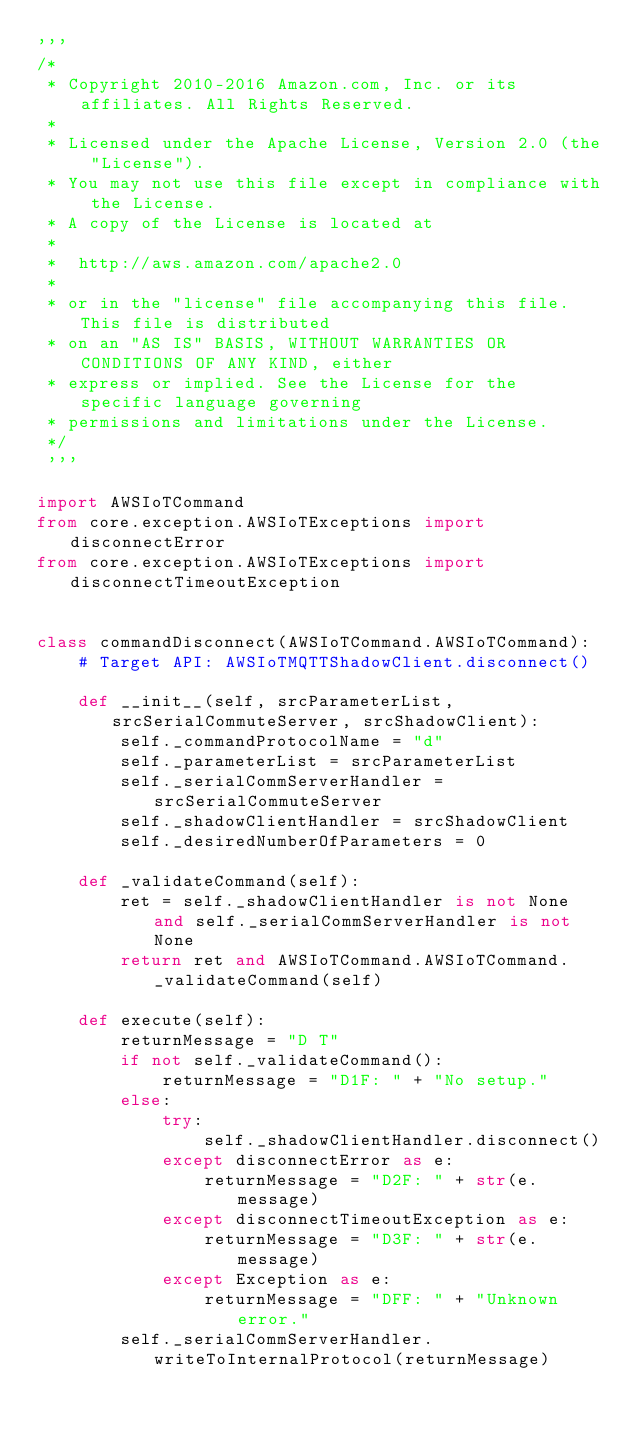<code> <loc_0><loc_0><loc_500><loc_500><_Python_>'''
/*
 * Copyright 2010-2016 Amazon.com, Inc. or its affiliates. All Rights Reserved.
 *
 * Licensed under the Apache License, Version 2.0 (the "License").
 * You may not use this file except in compliance with the License.
 * A copy of the License is located at
 *
 *  http://aws.amazon.com/apache2.0
 *
 * or in the "license" file accompanying this file. This file is distributed
 * on an "AS IS" BASIS, WITHOUT WARRANTIES OR CONDITIONS OF ANY KIND, either
 * express or implied. See the License for the specific language governing
 * permissions and limitations under the License.
 */
 '''

import AWSIoTCommand
from core.exception.AWSIoTExceptions import disconnectError
from core.exception.AWSIoTExceptions import disconnectTimeoutException


class commandDisconnect(AWSIoTCommand.AWSIoTCommand):
    # Target API: AWSIoTMQTTShadowClient.disconnect()

    def __init__(self, srcParameterList, srcSerialCommuteServer, srcShadowClient):
        self._commandProtocolName = "d"
        self._parameterList = srcParameterList
        self._serialCommServerHandler = srcSerialCommuteServer
        self._shadowClientHandler = srcShadowClient
        self._desiredNumberOfParameters = 0

    def _validateCommand(self):
        ret = self._shadowClientHandler is not None and self._serialCommServerHandler is not None
        return ret and AWSIoTCommand.AWSIoTCommand._validateCommand(self)

    def execute(self):
        returnMessage = "D T"
        if not self._validateCommand():
            returnMessage = "D1F: " + "No setup."
        else:
            try:
                self._shadowClientHandler.disconnect()
            except disconnectError as e:
                returnMessage = "D2F: " + str(e.message)
            except disconnectTimeoutException as e:
                returnMessage = "D3F: " + str(e.message)
            except Exception as e:
                returnMessage = "DFF: " + "Unknown error."
        self._serialCommServerHandler.writeToInternalProtocol(returnMessage)
</code> 